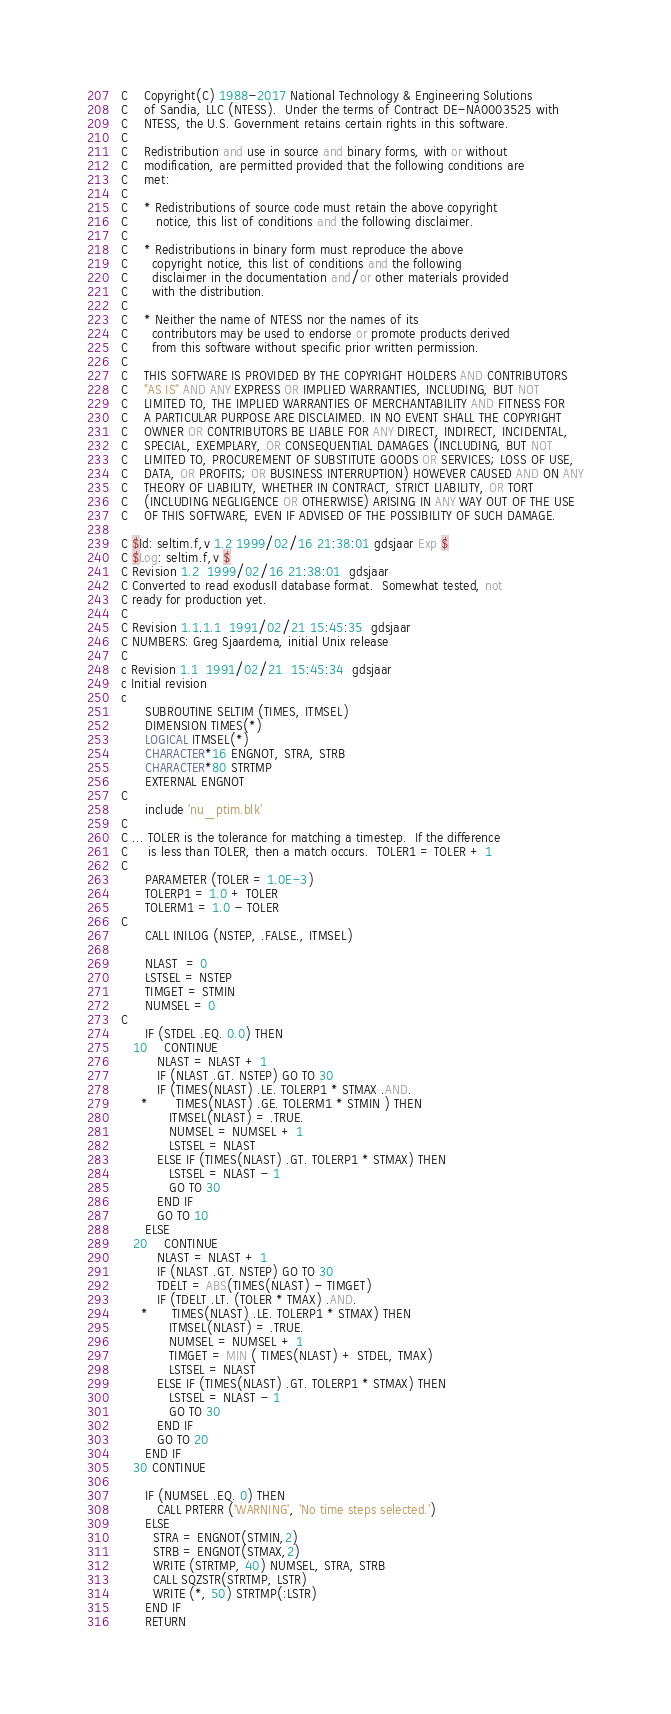Convert code to text. <code><loc_0><loc_0><loc_500><loc_500><_FORTRAN_>C    Copyright(C) 1988-2017 National Technology & Engineering Solutions
C    of Sandia, LLC (NTESS).  Under the terms of Contract DE-NA0003525 with
C    NTESS, the U.S. Government retains certain rights in this software.
C
C    Redistribution and use in source and binary forms, with or without
C    modification, are permitted provided that the following conditions are
C    met:
C
C    * Redistributions of source code must retain the above copyright
C       notice, this list of conditions and the following disclaimer.
C
C    * Redistributions in binary form must reproduce the above
C      copyright notice, this list of conditions and the following
C      disclaimer in the documentation and/or other materials provided
C      with the distribution.
C
C    * Neither the name of NTESS nor the names of its
C      contributors may be used to endorse or promote products derived
C      from this software without specific prior written permission.
C
C    THIS SOFTWARE IS PROVIDED BY THE COPYRIGHT HOLDERS AND CONTRIBUTORS
C    "AS IS" AND ANY EXPRESS OR IMPLIED WARRANTIES, INCLUDING, BUT NOT
C    LIMITED TO, THE IMPLIED WARRANTIES OF MERCHANTABILITY AND FITNESS FOR
C    A PARTICULAR PURPOSE ARE DISCLAIMED. IN NO EVENT SHALL THE COPYRIGHT
C    OWNER OR CONTRIBUTORS BE LIABLE FOR ANY DIRECT, INDIRECT, INCIDENTAL,
C    SPECIAL, EXEMPLARY, OR CONSEQUENTIAL DAMAGES (INCLUDING, BUT NOT
C    LIMITED TO, PROCUREMENT OF SUBSTITUTE GOODS OR SERVICES; LOSS OF USE,
C    DATA, OR PROFITS; OR BUSINESS INTERRUPTION) HOWEVER CAUSED AND ON ANY
C    THEORY OF LIABILITY, WHETHER IN CONTRACT, STRICT LIABILITY, OR TORT
C    (INCLUDING NEGLIGENCE OR OTHERWISE) ARISING IN ANY WAY OUT OF THE USE
C    OF THIS SOFTWARE, EVEN IF ADVISED OF THE POSSIBILITY OF SUCH DAMAGE.

C $Id: seltim.f,v 1.2 1999/02/16 21:38:01 gdsjaar Exp $
C $Log: seltim.f,v $
C Revision 1.2  1999/02/16 21:38:01  gdsjaar
C Converted to read exodusII database format.  Somewhat tested, not
C ready for production yet.
C
C Revision 1.1.1.1  1991/02/21 15:45:35  gdsjaar
C NUMBERS: Greg Sjaardema, initial Unix release
C
c Revision 1.1  1991/02/21  15:45:34  gdsjaar
c Initial revision
c
      SUBROUTINE SELTIM (TIMES, ITMSEL)
      DIMENSION TIMES(*)
      LOGICAL ITMSEL(*)
      CHARACTER*16 ENGNOT, STRA, STRB
      CHARACTER*80 STRTMP
      EXTERNAL ENGNOT
C
      include 'nu_ptim.blk'
C
C ... TOLER is the tolerance for matching a timestep.  If the difference
C     is less than TOLER, then a match occurs.  TOLER1 = TOLER + 1
C
      PARAMETER (TOLER = 1.0E-3)
      TOLERP1 = 1.0 + TOLER
      TOLERM1 = 1.0 - TOLER
C
      CALL INILOG (NSTEP, .FALSE., ITMSEL)

      NLAST  = 0
      LSTSEL = NSTEP
      TIMGET = STMIN
      NUMSEL = 0
C
      IF (STDEL .EQ. 0.0) THEN
   10    CONTINUE
         NLAST = NLAST + 1
         IF (NLAST .GT. NSTEP) GO TO 30
         IF (TIMES(NLAST) .LE. TOLERP1 * STMAX .AND.
     *       TIMES(NLAST) .GE. TOLERM1 * STMIN ) THEN
            ITMSEL(NLAST) = .TRUE.
            NUMSEL = NUMSEL + 1
            LSTSEL = NLAST
         ELSE IF (TIMES(NLAST) .GT. TOLERP1 * STMAX) THEN
            LSTSEL = NLAST - 1
            GO TO 30
         END IF
         GO TO 10
      ELSE
   20    CONTINUE
         NLAST = NLAST + 1
         IF (NLAST .GT. NSTEP) GO TO 30
         TDELT = ABS(TIMES(NLAST) - TIMGET)
         IF (TDELT .LT. (TOLER * TMAX) .AND.
     *      TIMES(NLAST) .LE. TOLERP1 * STMAX) THEN
            ITMSEL(NLAST) = .TRUE.
            NUMSEL = NUMSEL + 1
            TIMGET = MIN ( TIMES(NLAST) + STDEL, TMAX)
            LSTSEL = NLAST
         ELSE IF (TIMES(NLAST) .GT. TOLERP1 * STMAX) THEN
            LSTSEL = NLAST - 1
            GO TO 30
         END IF
         GO TO 20
      END IF
   30 CONTINUE

      IF (NUMSEL .EQ. 0) THEN
         CALL PRTERR ('WARNING', 'No time steps selected.')
      ELSE
        STRA = ENGNOT(STMIN,2)
        STRB = ENGNOT(STMAX,2)
        WRITE (STRTMP, 40) NUMSEL, STRA, STRB
        CALL SQZSTR(STRTMP, LSTR)
        WRITE (*, 50) STRTMP(:LSTR)
      END IF
      RETURN</code> 